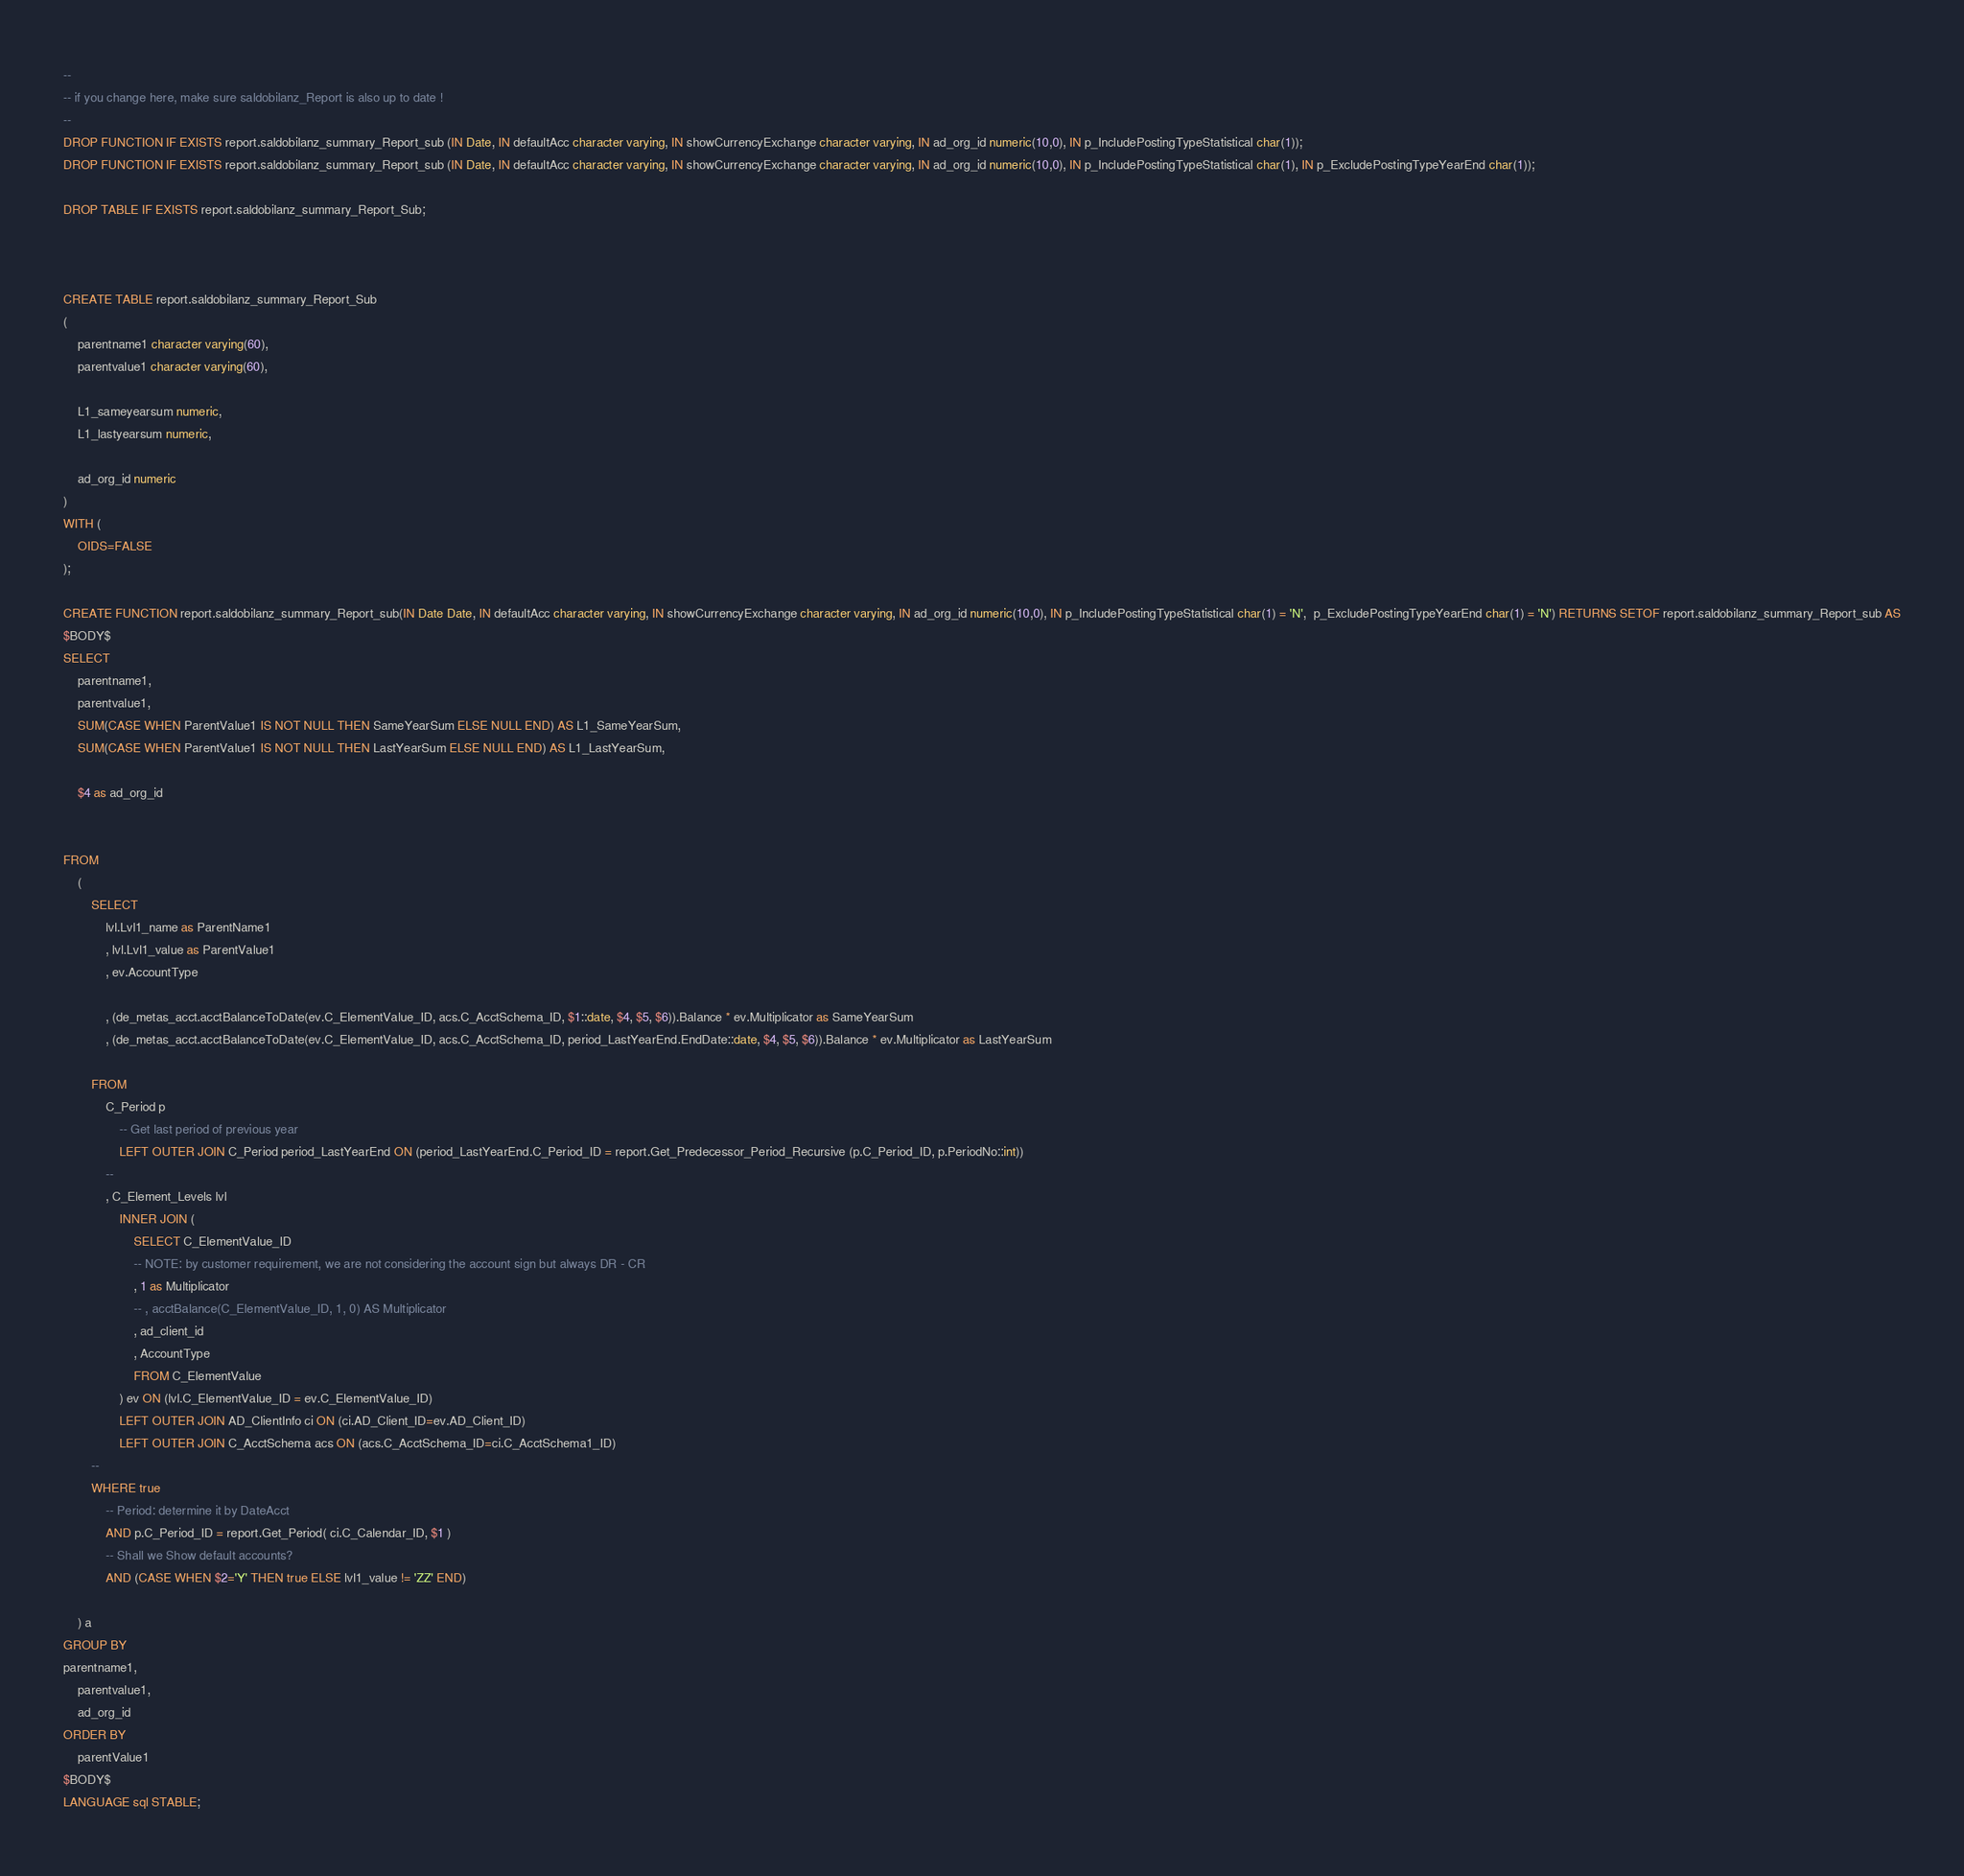<code> <loc_0><loc_0><loc_500><loc_500><_SQL_>--
-- if you change here, make sure saldobilanz_Report is also up to date !
--
DROP FUNCTION IF EXISTS report.saldobilanz_summary_Report_sub (IN Date, IN defaultAcc character varying, IN showCurrencyExchange character varying, IN ad_org_id numeric(10,0), IN p_IncludePostingTypeStatistical char(1));
DROP FUNCTION IF EXISTS report.saldobilanz_summary_Report_sub (IN Date, IN defaultAcc character varying, IN showCurrencyExchange character varying, IN ad_org_id numeric(10,0), IN p_IncludePostingTypeStatistical char(1), IN p_ExcludePostingTypeYearEnd char(1));

DROP TABLE IF EXISTS report.saldobilanz_summary_Report_Sub;



CREATE TABLE report.saldobilanz_summary_Report_Sub
(
	parentname1 character varying(60),
	parentvalue1 character varying(60),	

	L1_sameyearsum numeric,
	L1_lastyearsum numeric,
	
	ad_org_id numeric
)
WITH (
	OIDS=FALSE
);

CREATE FUNCTION report.saldobilanz_summary_Report_sub(IN Date Date, IN defaultAcc character varying, IN showCurrencyExchange character varying, IN ad_org_id numeric(10,0), IN p_IncludePostingTypeStatistical char(1) = 'N',  p_ExcludePostingTypeYearEnd char(1) = 'N') RETURNS SETOF report.saldobilanz_summary_Report_sub AS
$BODY$
SELECT
	parentname1,
	parentvalue1,
	SUM(CASE WHEN ParentValue1 IS NOT NULL THEN SameYearSum ELSE NULL END) AS L1_SameYearSum,
	SUM(CASE WHEN ParentValue1 IS NOT NULL THEN LastYearSum ELSE NULL END) AS L1_LastYearSum,
	
	$4 as ad_org_id


FROM
	(
		SELECT
			lvl.Lvl1_name as ParentName1
			, lvl.Lvl1_value as ParentValue1
			, ev.AccountType
			
			, (de_metas_acct.acctBalanceToDate(ev.C_ElementValue_ID, acs.C_AcctSchema_ID, $1::date, $4, $5, $6)).Balance * ev.Multiplicator as SameYearSum
			, (de_metas_acct.acctBalanceToDate(ev.C_ElementValue_ID, acs.C_AcctSchema_ID, period_LastYearEnd.EndDate::date, $4, $5, $6)).Balance * ev.Multiplicator as LastYearSum
				
		FROM
			C_Period p 
				-- Get last period of previous year
				LEFT OUTER JOIN C_Period period_LastYearEnd ON (period_LastYearEnd.C_Period_ID = report.Get_Predecessor_Period_Recursive (p.C_Period_ID, p.PeriodNo::int))
			--
			, C_Element_Levels lvl
				INNER JOIN (
					SELECT C_ElementValue_ID
					-- NOTE: by customer requirement, we are not considering the account sign but always DR - CR
					, 1 as Multiplicator
					-- , acctBalance(C_ElementValue_ID, 1, 0) AS Multiplicator
					, ad_client_id
					, AccountType
					FROM C_ElementValue
				) ev ON (lvl.C_ElementValue_ID = ev.C_ElementValue_ID)
				LEFT OUTER JOIN AD_ClientInfo ci ON (ci.AD_Client_ID=ev.AD_Client_ID)
				LEFT OUTER JOIN C_AcctSchema acs ON (acs.C_AcctSchema_ID=ci.C_AcctSchema1_ID)
		--
		WHERE true
			-- Period: determine it by DateAcct
			AND p.C_Period_ID = report.Get_Period( ci.C_Calendar_ID, $1 ) 
			-- Shall we Show default accounts?
			AND (CASE WHEN $2='Y' THEN true ELSE lvl1_value != 'ZZ' END)
			
	) a
GROUP BY 	
parentname1,
	parentvalue1,
	ad_org_id	
ORDER BY
	parentValue1
$BODY$
LANGUAGE sql STABLE;</code> 